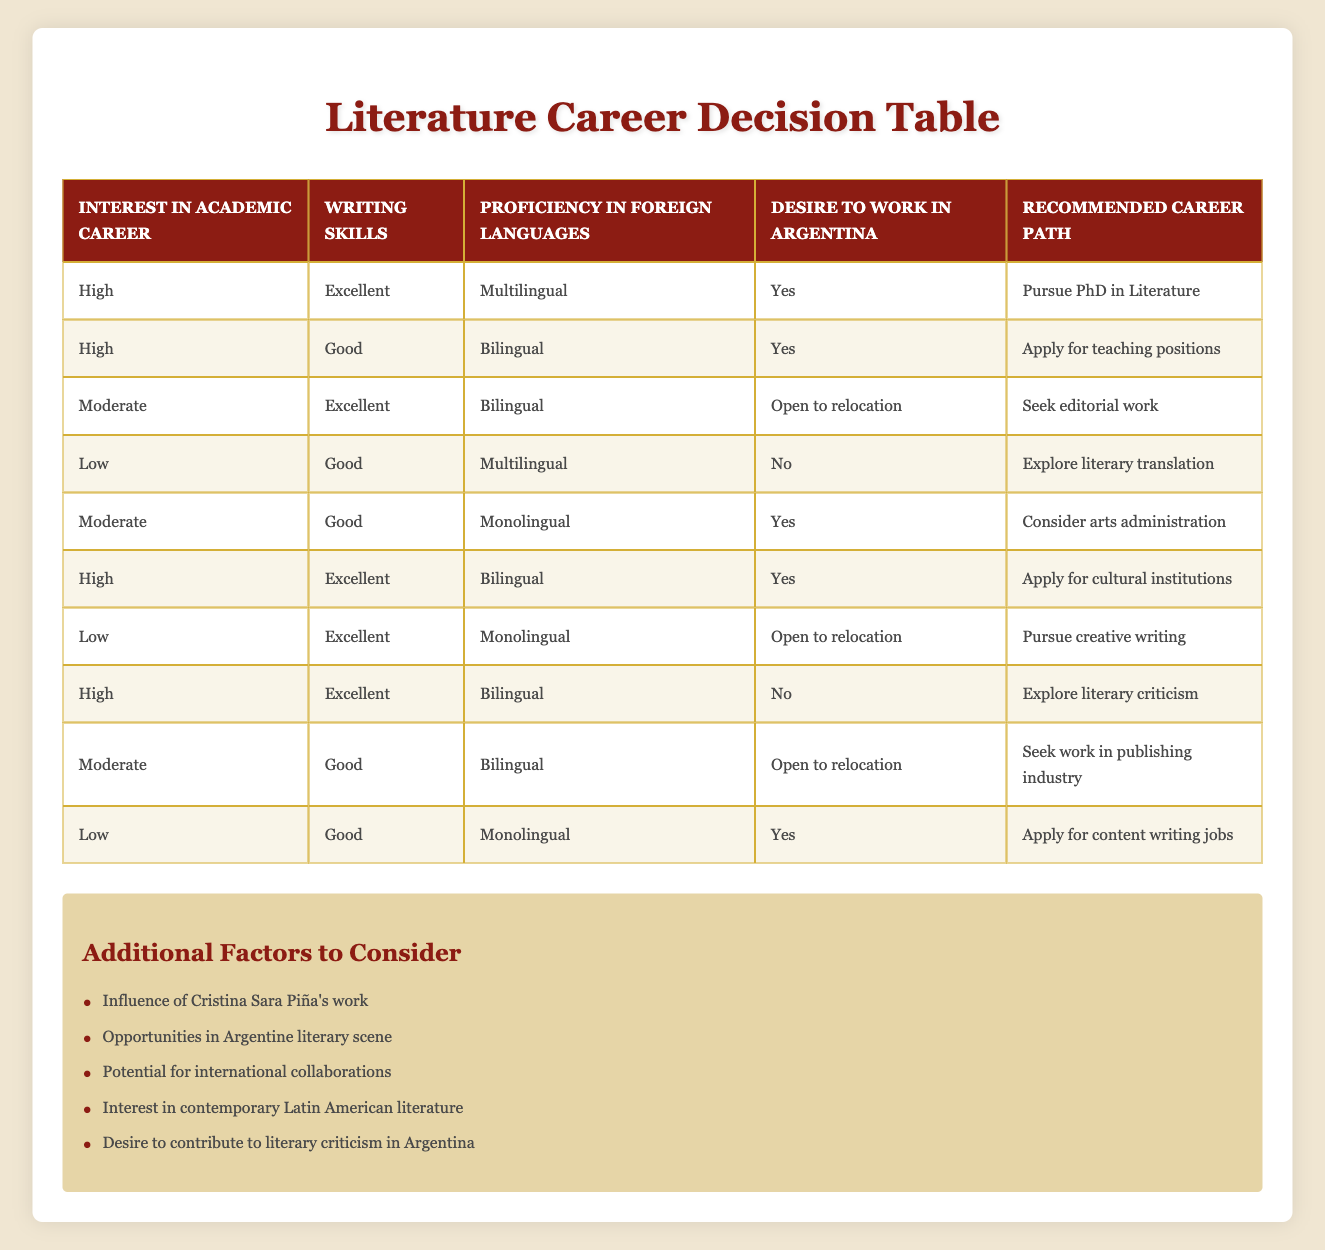What is the recommended career path for someone with a high interest in an academic career, excellent writing skills, multilingual proficiency, and a desire to work in Argentina? According to the table, this combination of conditions leads to the recommended career path of "Pursue PhD in Literature." This is found in the first row, where the specified conditions match exactly.
Answer: Pursue PhD in Literature How many career paths are suggested for individuals with moderate writing skills? By examining each row in the table, there are three situations with "Good" writing skills: one for arts administration, one for the publishing industry, and the remaining for teaching. Therefore, the total is three career paths.
Answer: Three Is it true that someone with low writing skills and monolingual proficiency can apply for cultural institutions? Looking at the relevant rows, individuals with "Low" writing skills in the table do not have a recommendation for applying to cultural institutions, as it is not present among the actions for the specified conditions of low writing skills.
Answer: No What can individuals with high writing skills and a desire to work outside of Argentina expect to pursue as a career path? Based on the table, individuals with "High" writing skills and a "No" to the desire to work in Argentina will explore "literary criticism," as noted in the relevant row under those conditions.
Answer: Explore literary criticism For someone who is bilingual and wants to work in publishing, what level of writing skills is recommended? The table shows that individuals who are bilingual and "Good" in writing skills should seek work in the publishing industry. This means that a "Good" level of writing skills is acceptable for this career path.
Answer: Good 